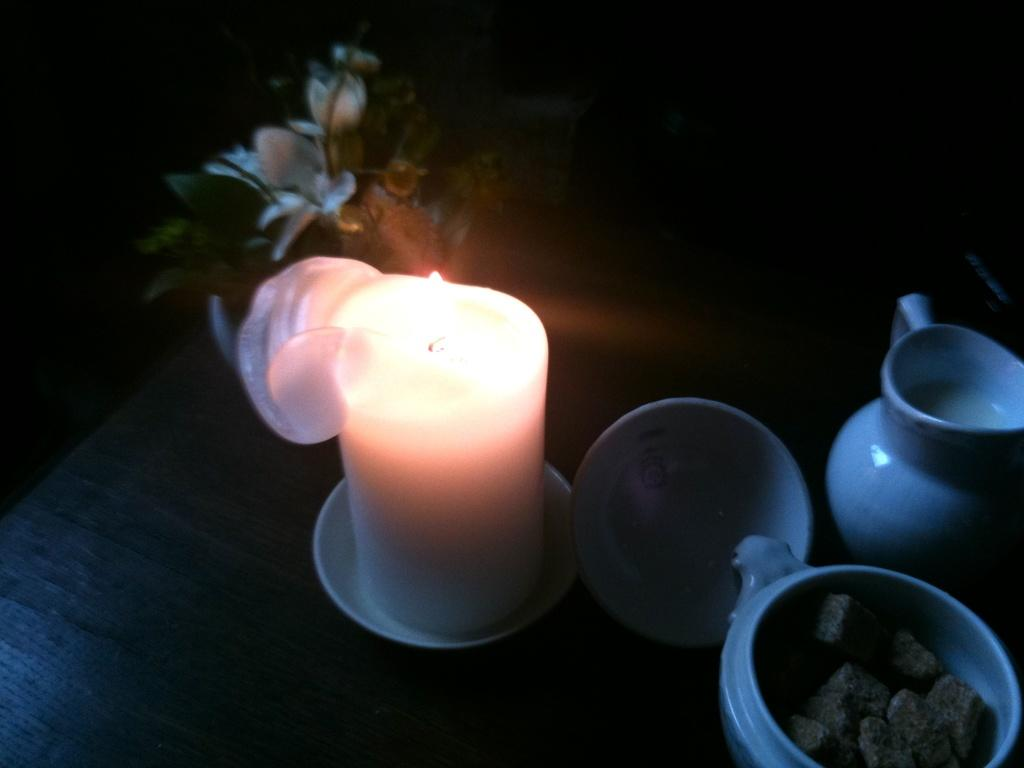What is the main object in the image? There is a candle in the image. What other objects can be seen in the image? There are bowls, a jug with liquid, a flower, buds, leaves, and a mug with objects in the image. What is the wooden platform used for? The objects are on a wooden platform, which suggests it might be a table or a surface for displaying or holding items. What type of flower is present in the image? The flower in the image is not specified, but it is present along with buds and leaves. What is the purpose of the patch in the image? There is no patch present in the image. 